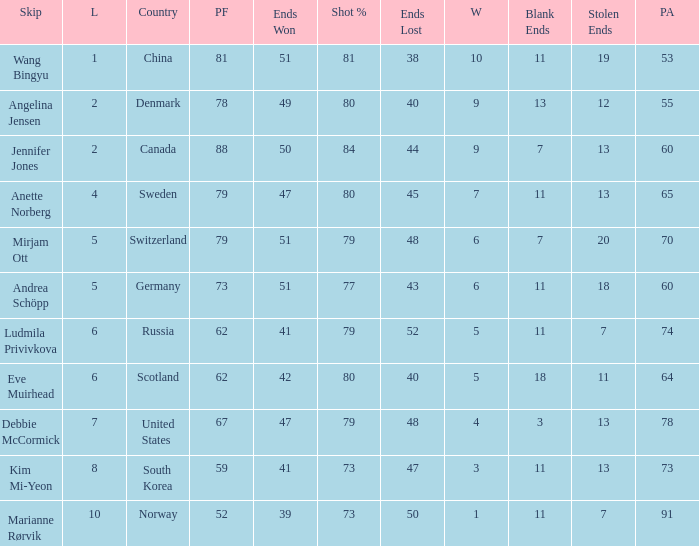Andrea Schöpp is the skip of which country? Germany. 